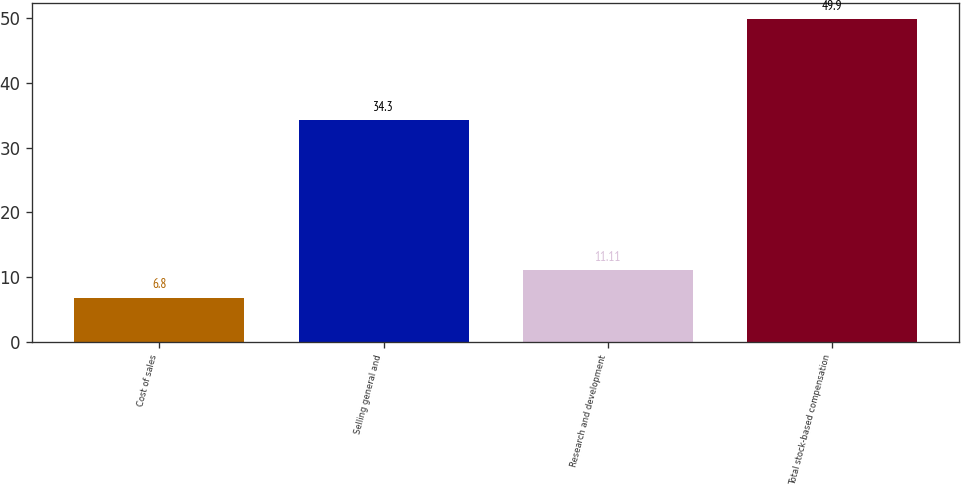<chart> <loc_0><loc_0><loc_500><loc_500><bar_chart><fcel>Cost of sales<fcel>Selling general and<fcel>Research and development<fcel>Total stock-based compensation<nl><fcel>6.8<fcel>34.3<fcel>11.11<fcel>49.9<nl></chart> 